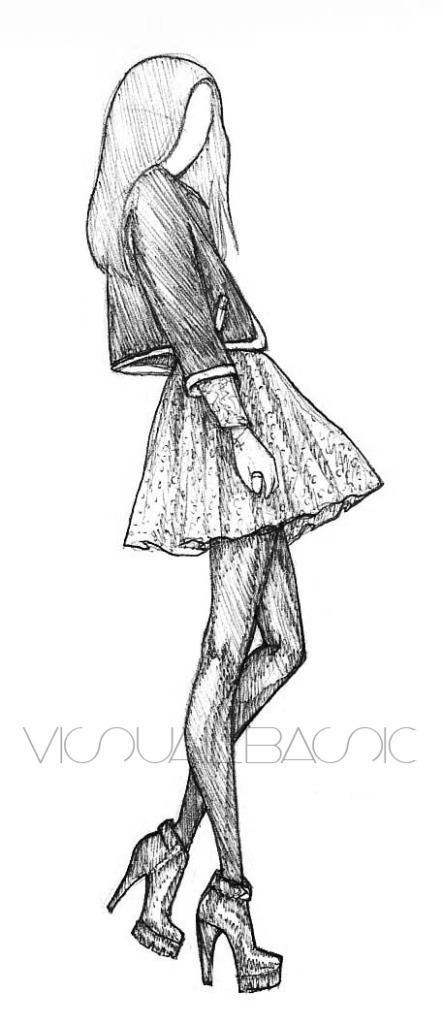What is the main subject of the image? The main subject of the image is a sketch of a girl. Can you describe the girl in the sketch? Unfortunately, the image only provides a sketch of the girl, so we cannot describe her in detail. How many beds are visible in the sketch of the girl? There are no beds visible in the sketch of the girl, as the image only contains a sketch of a girl and does not include any other objects or elements. 